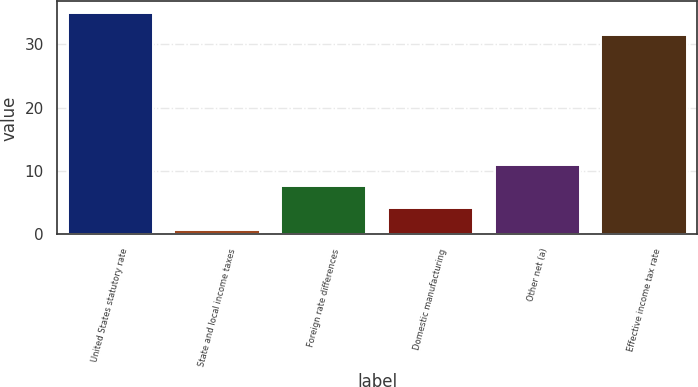Convert chart. <chart><loc_0><loc_0><loc_500><loc_500><bar_chart><fcel>United States statutory rate<fcel>State and local income taxes<fcel>Foreign rate differences<fcel>Domestic manufacturing<fcel>Other net (a)<fcel>Effective income tax rate<nl><fcel>35<fcel>0.7<fcel>7.56<fcel>4.13<fcel>10.99<fcel>31.4<nl></chart> 